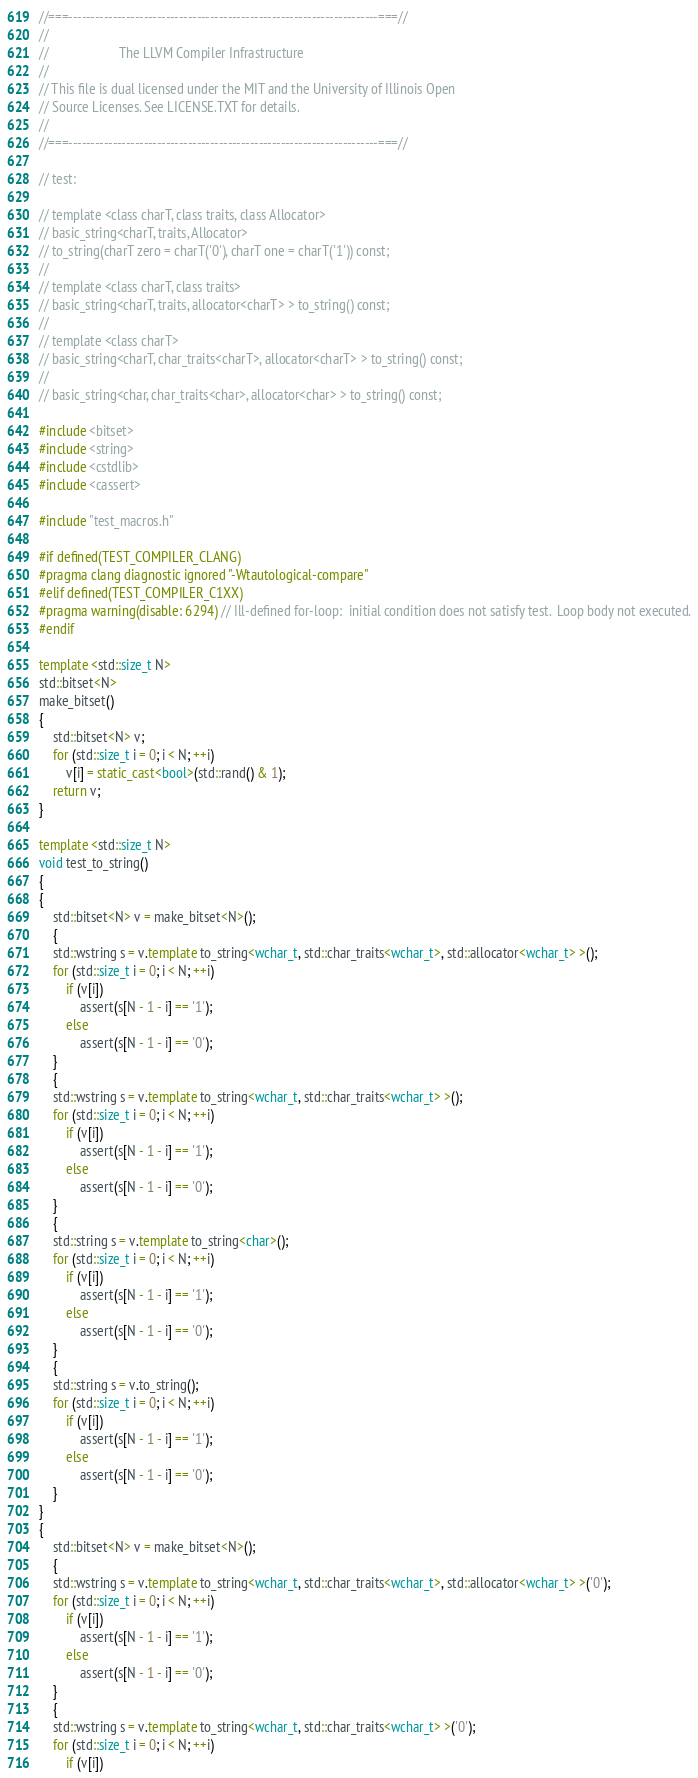<code> <loc_0><loc_0><loc_500><loc_500><_C++_>//===----------------------------------------------------------------------===//
//
//                     The LLVM Compiler Infrastructure
//
// This file is dual licensed under the MIT and the University of Illinois Open
// Source Licenses. See LICENSE.TXT for details.
//
//===----------------------------------------------------------------------===//

// test:

// template <class charT, class traits, class Allocator>
// basic_string<charT, traits, Allocator>
// to_string(charT zero = charT('0'), charT one = charT('1')) const;
//
// template <class charT, class traits>
// basic_string<charT, traits, allocator<charT> > to_string() const;
//
// template <class charT>
// basic_string<charT, char_traits<charT>, allocator<charT> > to_string() const;
//
// basic_string<char, char_traits<char>, allocator<char> > to_string() const;

#include <bitset>
#include <string>
#include <cstdlib>
#include <cassert>

#include "test_macros.h"

#if defined(TEST_COMPILER_CLANG)
#pragma clang diagnostic ignored "-Wtautological-compare"
#elif defined(TEST_COMPILER_C1XX)
#pragma warning(disable: 6294) // Ill-defined for-loop:  initial condition does not satisfy test.  Loop body not executed.
#endif

template <std::size_t N>
std::bitset<N>
make_bitset()
{
    std::bitset<N> v;
    for (std::size_t i = 0; i < N; ++i)
        v[i] = static_cast<bool>(std::rand() & 1);
    return v;
}

template <std::size_t N>
void test_to_string()
{
{
    std::bitset<N> v = make_bitset<N>();
    {
    std::wstring s = v.template to_string<wchar_t, std::char_traits<wchar_t>, std::allocator<wchar_t> >();
    for (std::size_t i = 0; i < N; ++i)
        if (v[i])
            assert(s[N - 1 - i] == '1');
        else
            assert(s[N - 1 - i] == '0');
    }
    {
    std::wstring s = v.template to_string<wchar_t, std::char_traits<wchar_t> >();
    for (std::size_t i = 0; i < N; ++i)
        if (v[i])
            assert(s[N - 1 - i] == '1');
        else
            assert(s[N - 1 - i] == '0');
    }
    {
    std::string s = v.template to_string<char>();
    for (std::size_t i = 0; i < N; ++i)
        if (v[i])
            assert(s[N - 1 - i] == '1');
        else
            assert(s[N - 1 - i] == '0');
    }
    {
    std::string s = v.to_string();
    for (std::size_t i = 0; i < N; ++i)
        if (v[i])
            assert(s[N - 1 - i] == '1');
        else
            assert(s[N - 1 - i] == '0');
    }
}
{
    std::bitset<N> v = make_bitset<N>();
    {
    std::wstring s = v.template to_string<wchar_t, std::char_traits<wchar_t>, std::allocator<wchar_t> >('0');
    for (std::size_t i = 0; i < N; ++i)
        if (v[i])
            assert(s[N - 1 - i] == '1');
        else
            assert(s[N - 1 - i] == '0');
    }
    {
    std::wstring s = v.template to_string<wchar_t, std::char_traits<wchar_t> >('0');
    for (std::size_t i = 0; i < N; ++i)
        if (v[i])</code> 